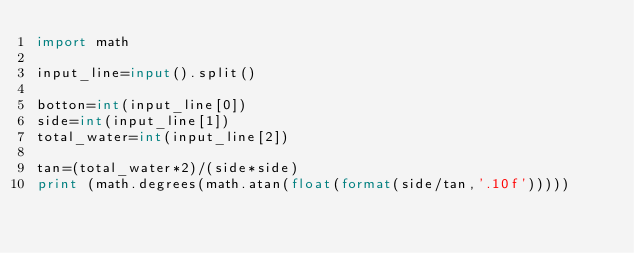<code> <loc_0><loc_0><loc_500><loc_500><_Python_>import math

input_line=input().split()

botton=int(input_line[0])
side=int(input_line[1])
total_water=int(input_line[2])

tan=(total_water*2)/(side*side)
print (math.degrees(math.atan(float(format(side/tan,'.10f')))))</code> 